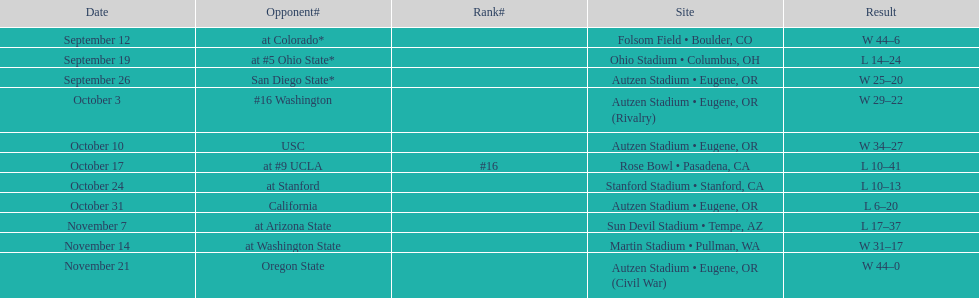Did the team win or lose more games? Win. Could you parse the entire table as a dict? {'header': ['Date', 'Opponent#', 'Rank#', 'Site', 'Result'], 'rows': [['September 12', 'at\xa0Colorado*', '', 'Folsom Field • Boulder, CO', 'W\xa044–6'], ['September 19', 'at\xa0#5\xa0Ohio State*', '', 'Ohio Stadium • Columbus, OH', 'L\xa014–24'], ['September 26', 'San Diego State*', '', 'Autzen Stadium • Eugene, OR', 'W\xa025–20'], ['October 3', '#16\xa0Washington', '', 'Autzen Stadium • Eugene, OR (Rivalry)', 'W\xa029–22'], ['October 10', 'USC', '', 'Autzen Stadium • Eugene, OR', 'W\xa034–27'], ['October 17', 'at\xa0#9\xa0UCLA', '#16', 'Rose Bowl • Pasadena, CA', 'L\xa010–41'], ['October 24', 'at\xa0Stanford', '', 'Stanford Stadium • Stanford, CA', 'L\xa010–13'], ['October 31', 'California', '', 'Autzen Stadium • Eugene, OR', 'L\xa06–20'], ['November 7', 'at\xa0Arizona State', '', 'Sun Devil Stadium • Tempe, AZ', 'L\xa017–37'], ['November 14', 'at\xa0Washington State', '', 'Martin Stadium • Pullman, WA', 'W\xa031–17'], ['November 21', 'Oregon State', '', 'Autzen Stadium • Eugene, OR (Civil War)', 'W\xa044–0']]} 